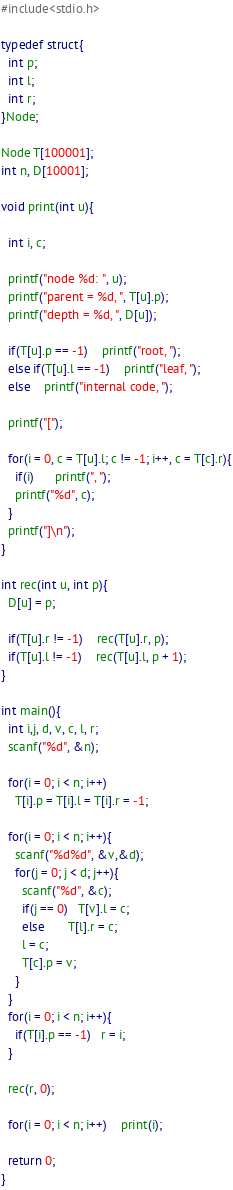Convert code to text. <code><loc_0><loc_0><loc_500><loc_500><_C_>#include<stdio.h>

typedef struct{
  int p;
  int l;
  int r;
}Node; 

Node T[100001];
int n, D[10001];

void print(int u){

  int i, c;

  printf("node %d: ", u);
  printf("parent = %d, ", T[u].p);
  printf("depth = %d, ", D[u]);

  if(T[u].p == -1)    printf("root, ");
  else if(T[u].l == -1)    printf("leaf, ");
  else    printf("internal code, ");
  
  printf("[");
  
  for(i = 0, c = T[u].l; c != -1; i++, c = T[c].r){
    if(i)      printf(", ");
    printf("%d", c);
  }
  printf("]\n");
}
      
int rec(int u, int p){
  D[u] = p;

  if(T[u].r != -1)    rec(T[u].r, p);
  if(T[u].l != -1)    rec(T[u].l, p + 1);
}

int main(){
  int i,j, d, v, c, l, r;
  scanf("%d", &n);

  for(i = 0; i < n; i++)
    T[i].p = T[i].l = T[i].r = -1;
  
  for(i = 0; i < n; i++){
    scanf("%d%d", &v,&d);
    for(j = 0; j < d; j++){
      scanf("%d", &c);
      if(j == 0)   T[v].l = c;
      else	   T[l].r = c;
      l = c;
      T[c].p = v;
    }
  }
  for(i = 0; i < n; i++){
    if(T[i].p == -1)   r = i;
  }
  
  rec(r, 0);

  for(i = 0; i < n; i++)    print(i);

  return 0;
}</code> 